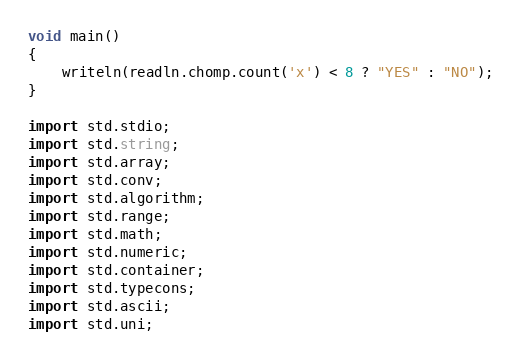Convert code to text. <code><loc_0><loc_0><loc_500><loc_500><_D_>void main()
{
    writeln(readln.chomp.count('x') < 8 ? "YES" : "NO");
}

import std.stdio;
import std.string;
import std.array;
import std.conv;
import std.algorithm;
import std.range;
import std.math;
import std.numeric;
import std.container;
import std.typecons;
import std.ascii;
import std.uni;</code> 